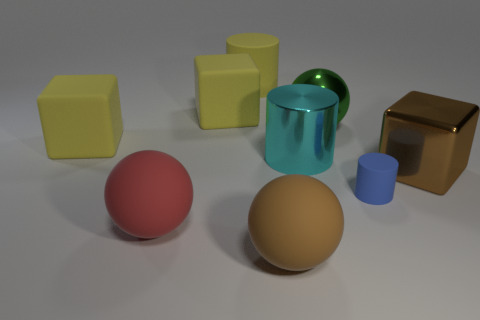Add 1 big gray blocks. How many objects exist? 10 Subtract all large matte spheres. How many spheres are left? 1 Subtract all purple cylinders. How many yellow blocks are left? 2 Subtract 1 cubes. How many cubes are left? 2 Subtract all cylinders. How many objects are left? 6 Subtract all green blocks. Subtract all brown balls. How many blocks are left? 3 Subtract all large rubber cylinders. Subtract all tiny cylinders. How many objects are left? 7 Add 1 matte spheres. How many matte spheres are left? 3 Add 8 big cyan metal things. How many big cyan metal things exist? 9 Subtract 0 gray cubes. How many objects are left? 9 